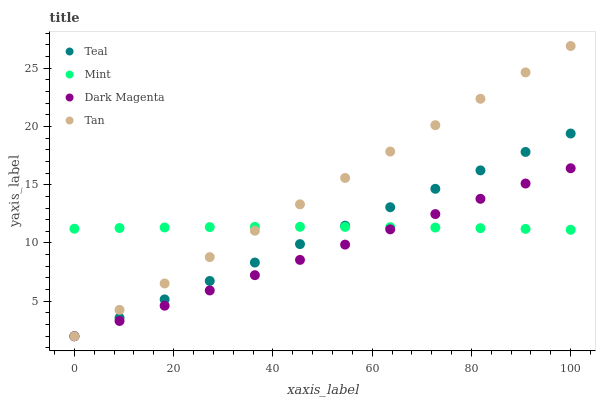Does Dark Magenta have the minimum area under the curve?
Answer yes or no. Yes. Does Tan have the maximum area under the curve?
Answer yes or no. Yes. Does Mint have the minimum area under the curve?
Answer yes or no. No. Does Mint have the maximum area under the curve?
Answer yes or no. No. Is Dark Magenta the smoothest?
Answer yes or no. Yes. Is Mint the roughest?
Answer yes or no. Yes. Is Mint the smoothest?
Answer yes or no. No. Is Dark Magenta the roughest?
Answer yes or no. No. Does Tan have the lowest value?
Answer yes or no. Yes. Does Mint have the lowest value?
Answer yes or no. No. Does Tan have the highest value?
Answer yes or no. Yes. Does Dark Magenta have the highest value?
Answer yes or no. No. Does Teal intersect Tan?
Answer yes or no. Yes. Is Teal less than Tan?
Answer yes or no. No. Is Teal greater than Tan?
Answer yes or no. No. 